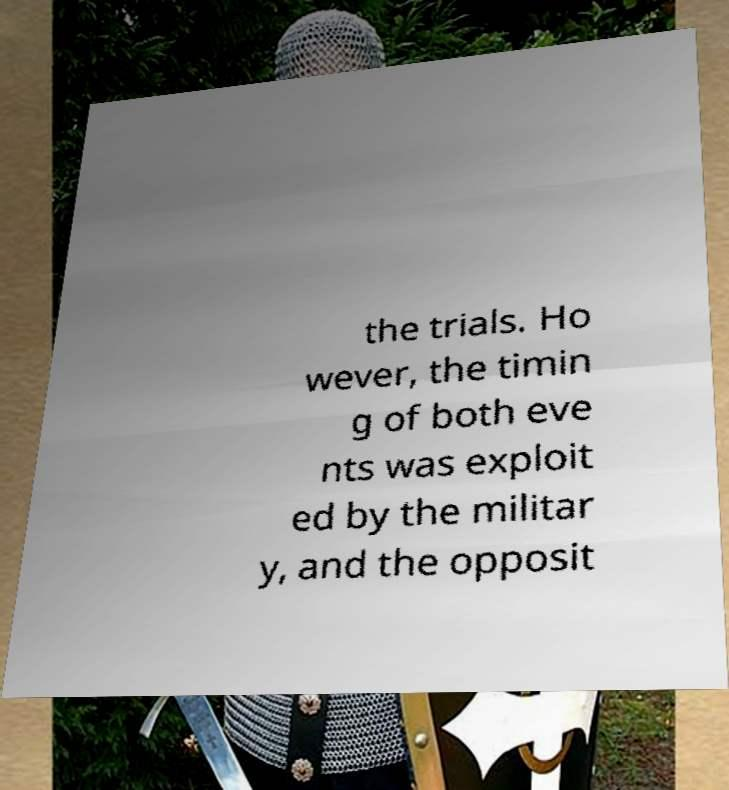Could you assist in decoding the text presented in this image and type it out clearly? the trials. Ho wever, the timin g of both eve nts was exploit ed by the militar y, and the opposit 